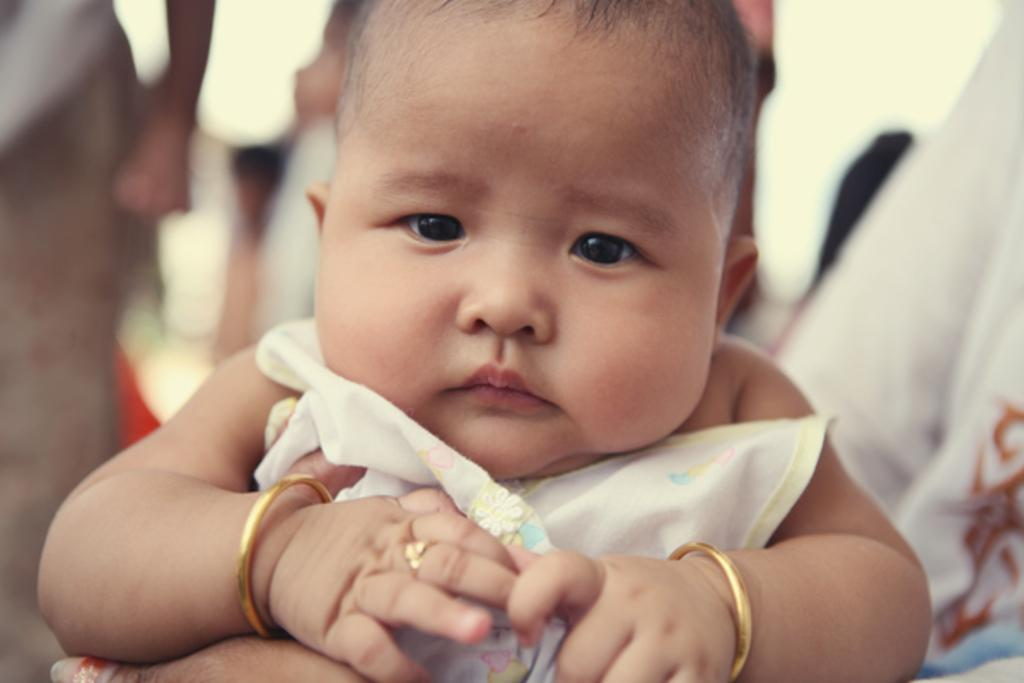What is the main subject of the image? There is a baby in the center of the image. What type of owl can be seen on the island in the image? There is no owl or island present in the image; it features a baby in the center. What type of flesh is visible on the baby in the image? There is no flesh visible on the baby in the image; it is a photograph or illustration, not a real-life depiction. 